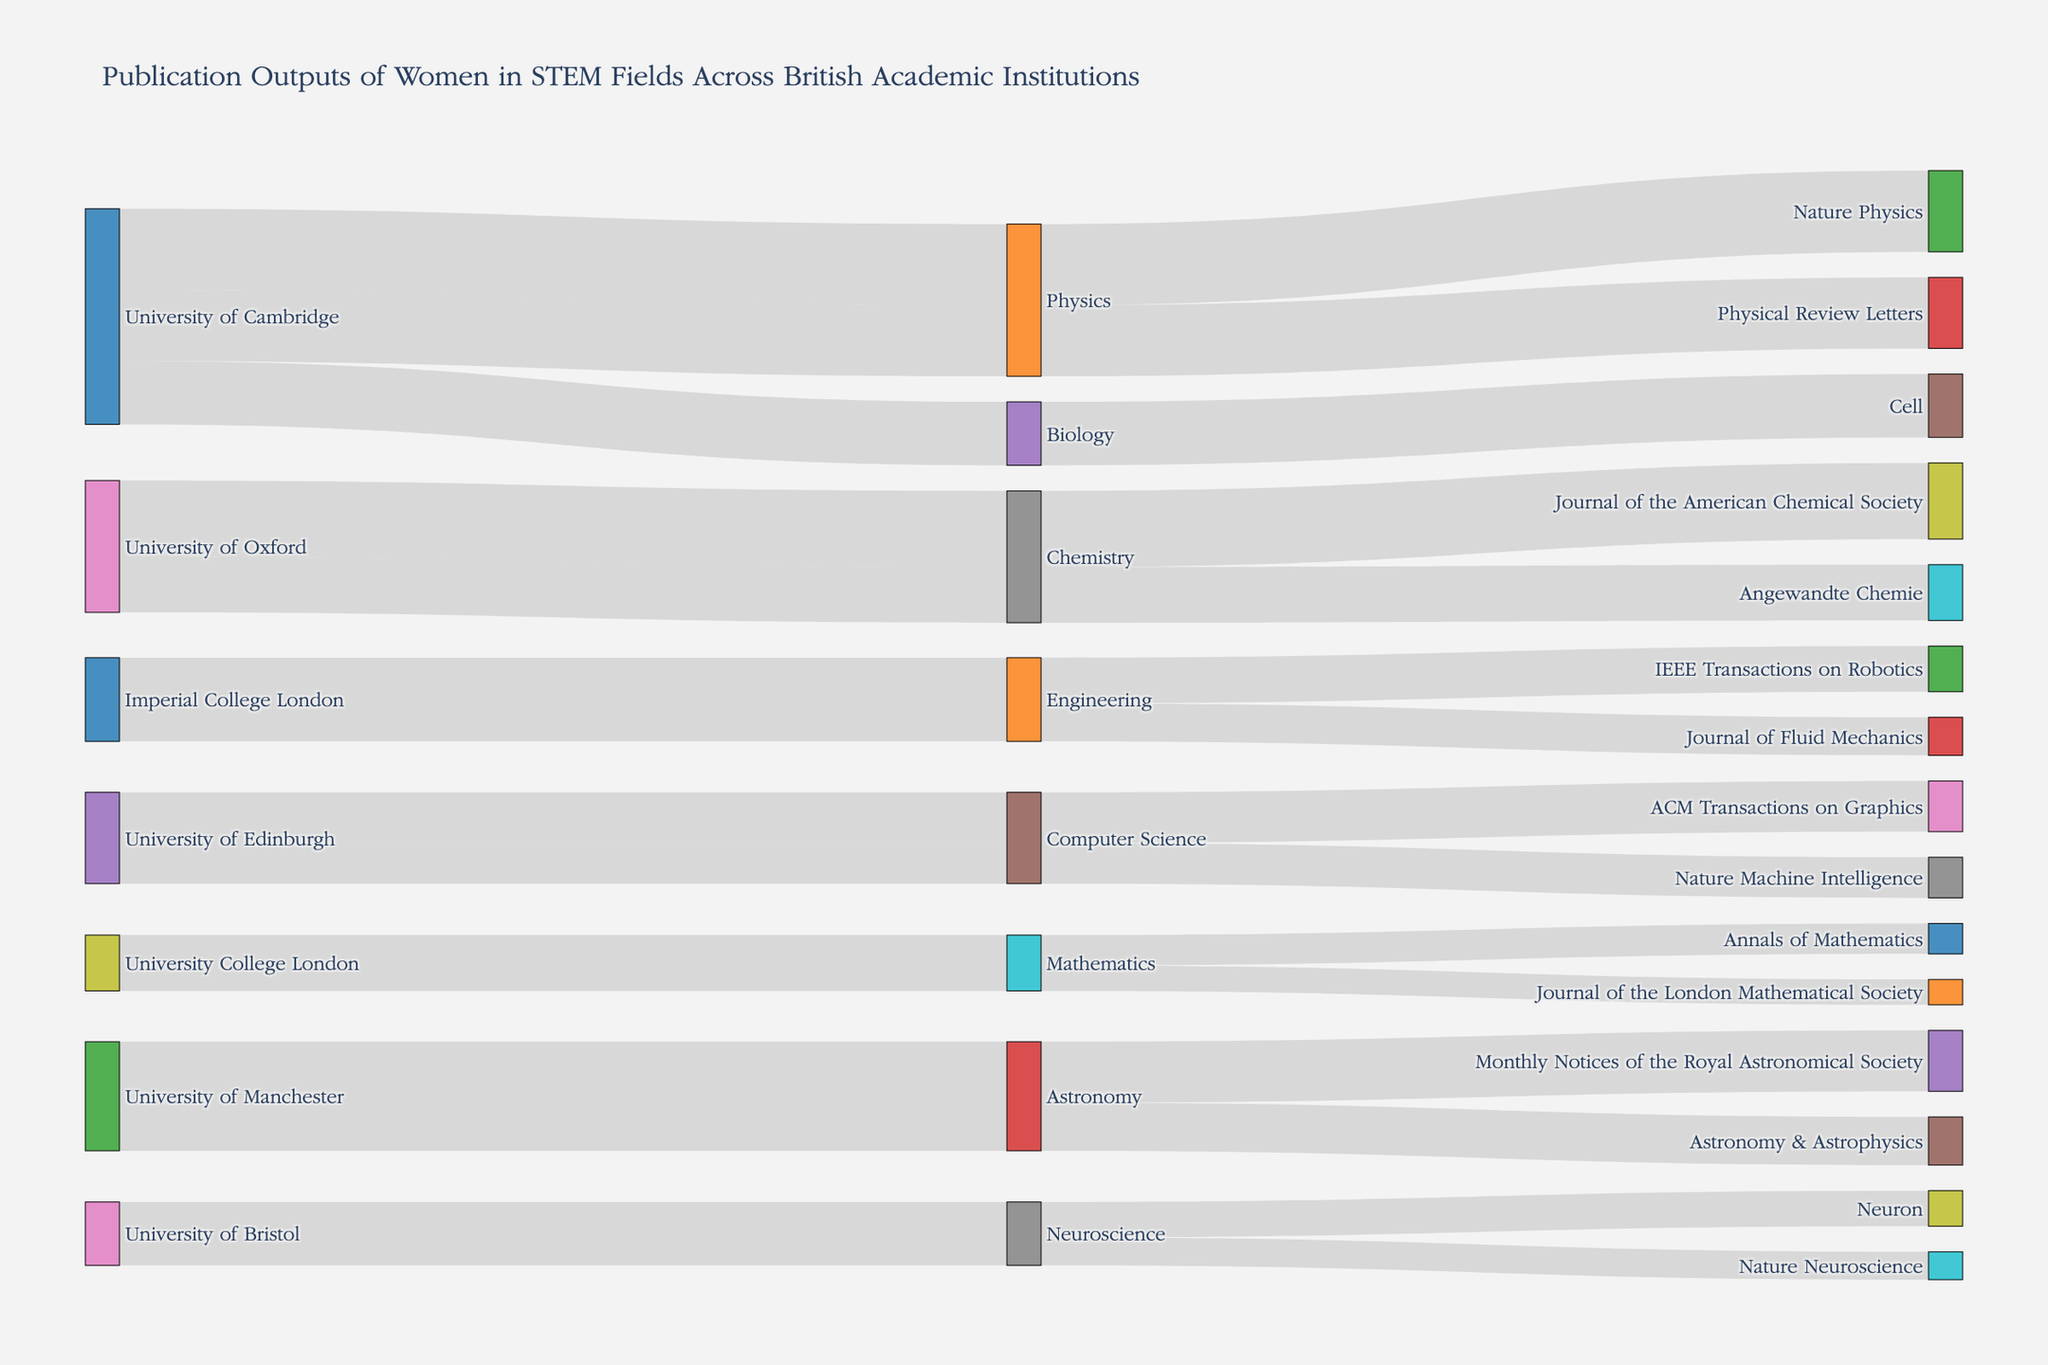What's the title of the figure? The title is usually located at the top of the figure.
Answer: Publication Outputs of Women in STEM Fields Across British Academic Institutions Which academic institutions are represented in the figure? The Sankey diagram includes labels that represent different academic institutions.
Answer: University of Cambridge, University of Oxford, Imperial College London, University of Edinburgh, University College London, University of Manchester, University of Bristol What is the total number of publications for the University of Cambridge in Physics? First, locate the sections for the University of Cambridge and Physics, then sum the publication values for Nature Physics and Physical Review Letters. The values are 32 and 28, respectively. 32 + 28 = 60
Answer: 60 Which field has the most diverse range of journals represented in the figure? Identify the fields and count the number of unique journals associated with each field. Biology, for instance, is connected to Cell, whereas other fields like Chemistry and Engineering have multiple journals listed.
Answer: Chemistry and Physics (tie) How does the number of publications in Cell compare to those in Nature Physics from the University of Cambridge? Compare the publication count for each journal listed under the University of Cambridge. Nature Physics has 32 publications and Cell has 25.
Answer: Nature Physics has more publications Which journal has the highest number of publications from the University of Oxford? Look at the links leading from the University of Oxford to journals and identify the one with the highest publication count.
Answer: Journal of the American Chemical Society What is the combined number of publications from Imperial College London in Engineering? Calculate the total number of publications by adding the values for IEEE Transactions on Robotics (18) and Journal of Fluid Mechanics (15). 18 + 15 = 33
Answer: 33 Is the number of publications in Astronomy greater at the University of Manchester than the number of publications in Computer Science at the University of Edinburgh? Compare the total publications in Astronomy from the University of Manchester (24 + 19 = 43) to those in Computer Science from the University of Edinburgh (20 + 16 = 36).
Answer: Yes, greater How many academic institutions are involved in publishing papers in Neuroscience? Identify the nodes labeled with institutions connected to Neuroscience.
Answer: 1 (University of Bristol) Which journal appears the least number of times across all fields? Scan the figure to identify journals and count their occurrences. Journals like the Journal of the London Mathematical Society occur only once whereas others might be repeated.
Answer: Journal of the London Mathematical Society, Annals of Mathematics 